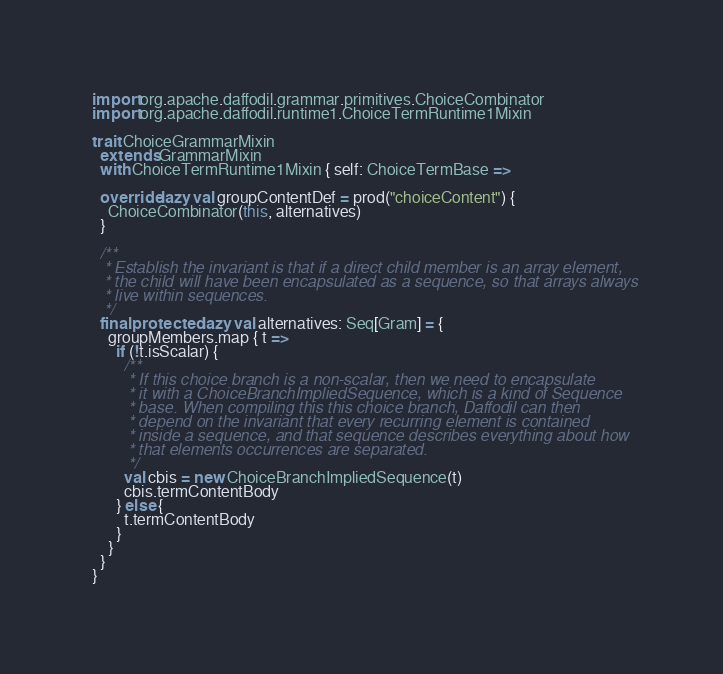<code> <loc_0><loc_0><loc_500><loc_500><_Scala_>import org.apache.daffodil.grammar.primitives.ChoiceCombinator
import org.apache.daffodil.runtime1.ChoiceTermRuntime1Mixin

trait ChoiceGrammarMixin
  extends GrammarMixin
  with ChoiceTermRuntime1Mixin { self: ChoiceTermBase =>

  override lazy val groupContentDef = prod("choiceContent") {
    ChoiceCombinator(this, alternatives)
  }

  /**
   * Establish the invariant is that if a direct child member is an array element,
   * the child will have been encapsulated as a sequence, so that arrays always
   * live within sequences.
   */
  final protected lazy val alternatives: Seq[Gram] = {
    groupMembers.map { t =>
      if (!t.isScalar) {
        /**
         * If this choice branch is a non-scalar, then we need to encapsulate
         * it with a ChoiceBranchImpliedSequence, which is a kind of Sequence
         * base. When compiling this this choice branch, Daffodil can then
         * depend on the invariant that every recurring element is contained
         * inside a sequence, and that sequence describes everything about how
         * that elements occurrences are separated.
         */
        val cbis = new ChoiceBranchImpliedSequence(t)
        cbis.termContentBody
      } else {
        t.termContentBody
      }
    }
  }
}
</code> 